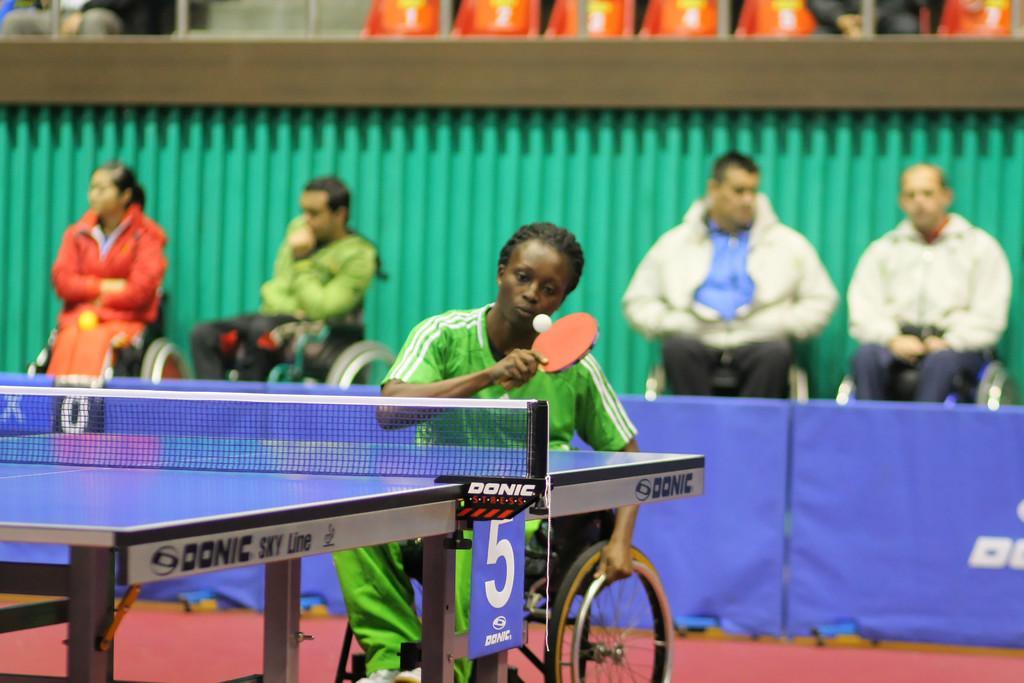Please provide a concise description of this image. In this image we can see a women playing a table tennis game by sitting on wheel chair, in background we can see four people sitting on wheelchairs and also we can see hoarding in front of them. 